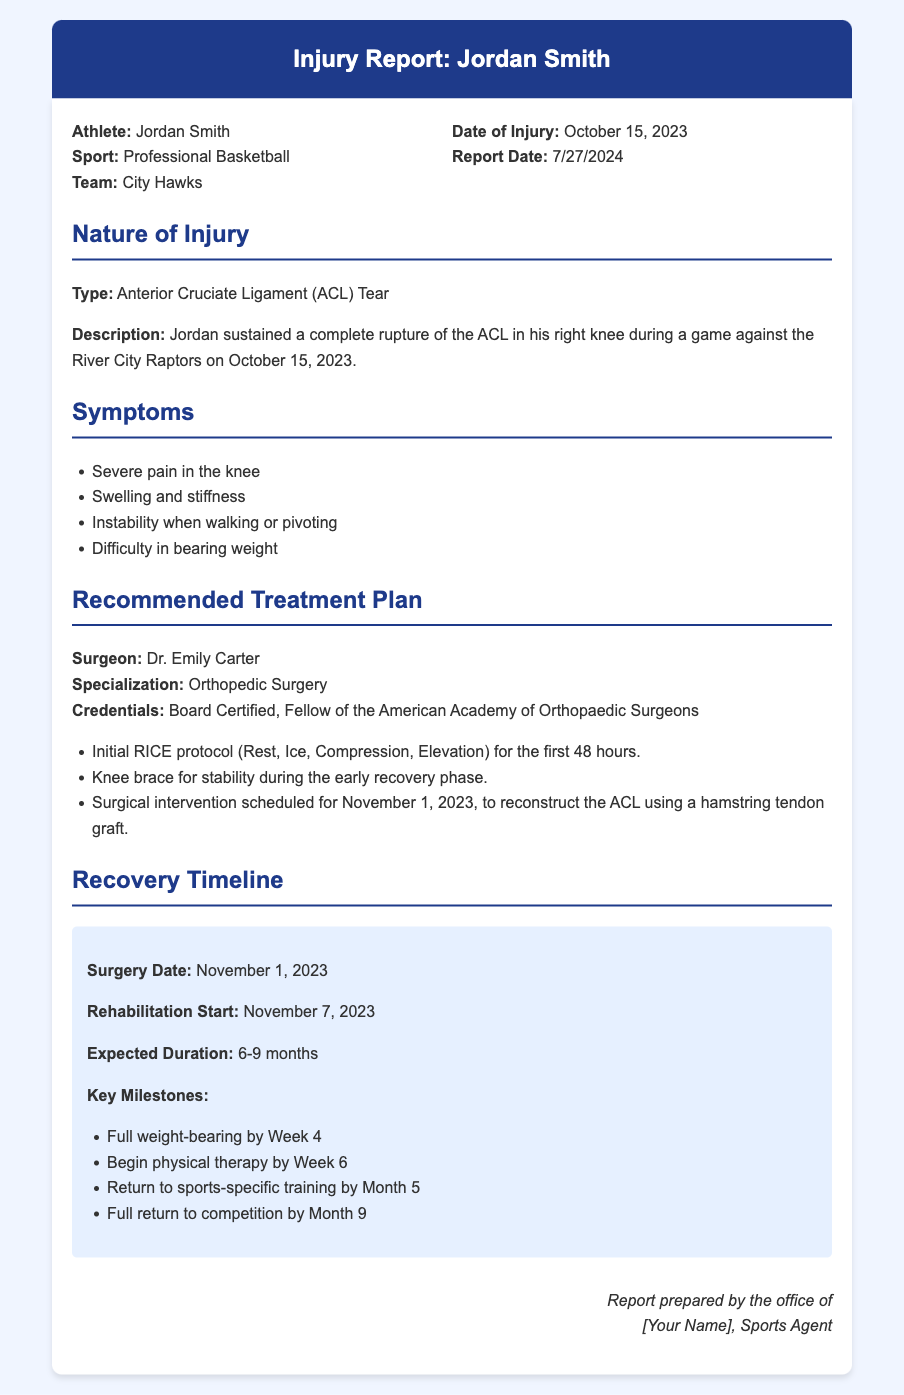What is the athlete's name? The document states that the athlete's name is Jordan Smith.
Answer: Jordan Smith What type of injury did Jordan sustain? The nature of the injury is described as an Anterior Cruciate Ligament (ACL) Tear.
Answer: Anterior Cruciate Ligament (ACL) Tear When is the surgical intervention scheduled? The document specifies the surgical intervention date as November 1, 2023.
Answer: November 1, 2023 What are the key milestones for recovery? The document lists milestones such as full weight-bearing by Week 4 and return to competition by Month 9.
Answer: Full weight-bearing by Week 4, Full return to competition by Month 9 Who is the recommended surgeon for the treatment? The surgeon recommended in the document is Dr. Emily Carter.
Answer: Dr. Emily Carter What is the expected duration of rehabilitation? The expected duration of rehabilitation mentioned in the document is 6-9 months.
Answer: 6-9 months What symptoms did Jordan experience? The symptoms listed include severe pain, swelling, and instability when walking.
Answer: Severe pain, swelling, instability What treatment is recommended during the early recovery phase? The document suggests using a knee brace for stability during early recovery.
Answer: Knee brace for stability When did the injury occur? According to the document, the injury occurred on October 15, 2023.
Answer: October 15, 2023 